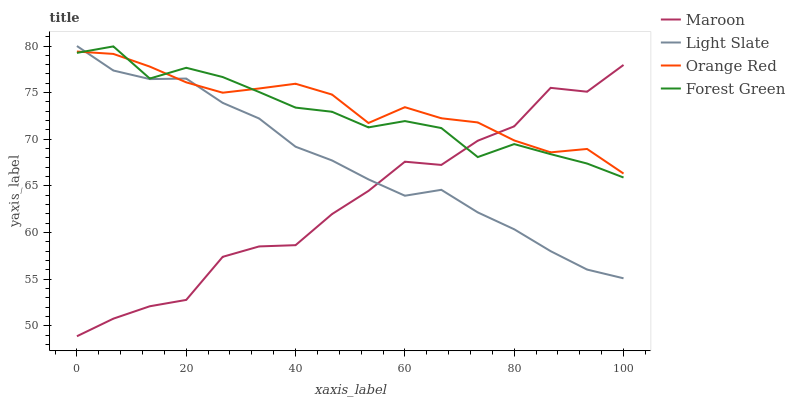Does Forest Green have the minimum area under the curve?
Answer yes or no. No. Does Forest Green have the maximum area under the curve?
Answer yes or no. No. Is Forest Green the smoothest?
Answer yes or no. No. Is Forest Green the roughest?
Answer yes or no. No. Does Forest Green have the lowest value?
Answer yes or no. No. Does Forest Green have the highest value?
Answer yes or no. No. 